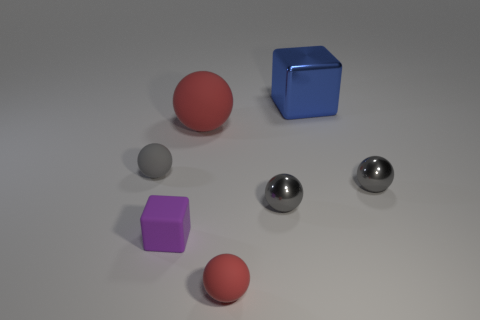How many big red balls are behind the tiny rubber ball that is right of the large rubber object?
Provide a succinct answer. 1. There is a matte thing that is the same size as the blue metallic thing; what is its color?
Keep it short and to the point. Red. What is the material of the large object that is on the left side of the big shiny thing?
Ensure brevity in your answer.  Rubber. The gray ball that is both to the left of the blue metal block and on the right side of the large matte ball is made of what material?
Provide a short and direct response. Metal. Is the size of the metallic ball to the right of the blue object the same as the blue cube?
Your response must be concise. No. The big metal thing is what shape?
Ensure brevity in your answer.  Cube. How many tiny shiny objects are the same shape as the purple matte thing?
Offer a very short reply. 0. What number of cubes are to the right of the purple rubber block and in front of the large blue block?
Your answer should be very brief. 0. What is the color of the big sphere?
Your answer should be compact. Red. Are there any tiny spheres that have the same material as the tiny red thing?
Your answer should be compact. Yes. 